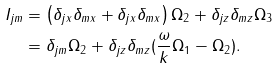<formula> <loc_0><loc_0><loc_500><loc_500>I _ { j m } & = \left ( \delta _ { j x } \delta _ { m x } + \delta _ { j x } \delta _ { m x } \right ) \Omega _ { 2 } + \delta _ { j z } \delta _ { m z } \Omega _ { 3 } \\ & = \delta _ { j m } \Omega _ { 2 } + \delta _ { j z } \delta _ { m z } ( \frac { \omega } { k } \Omega _ { 1 } - \Omega _ { 2 } ) .</formula> 